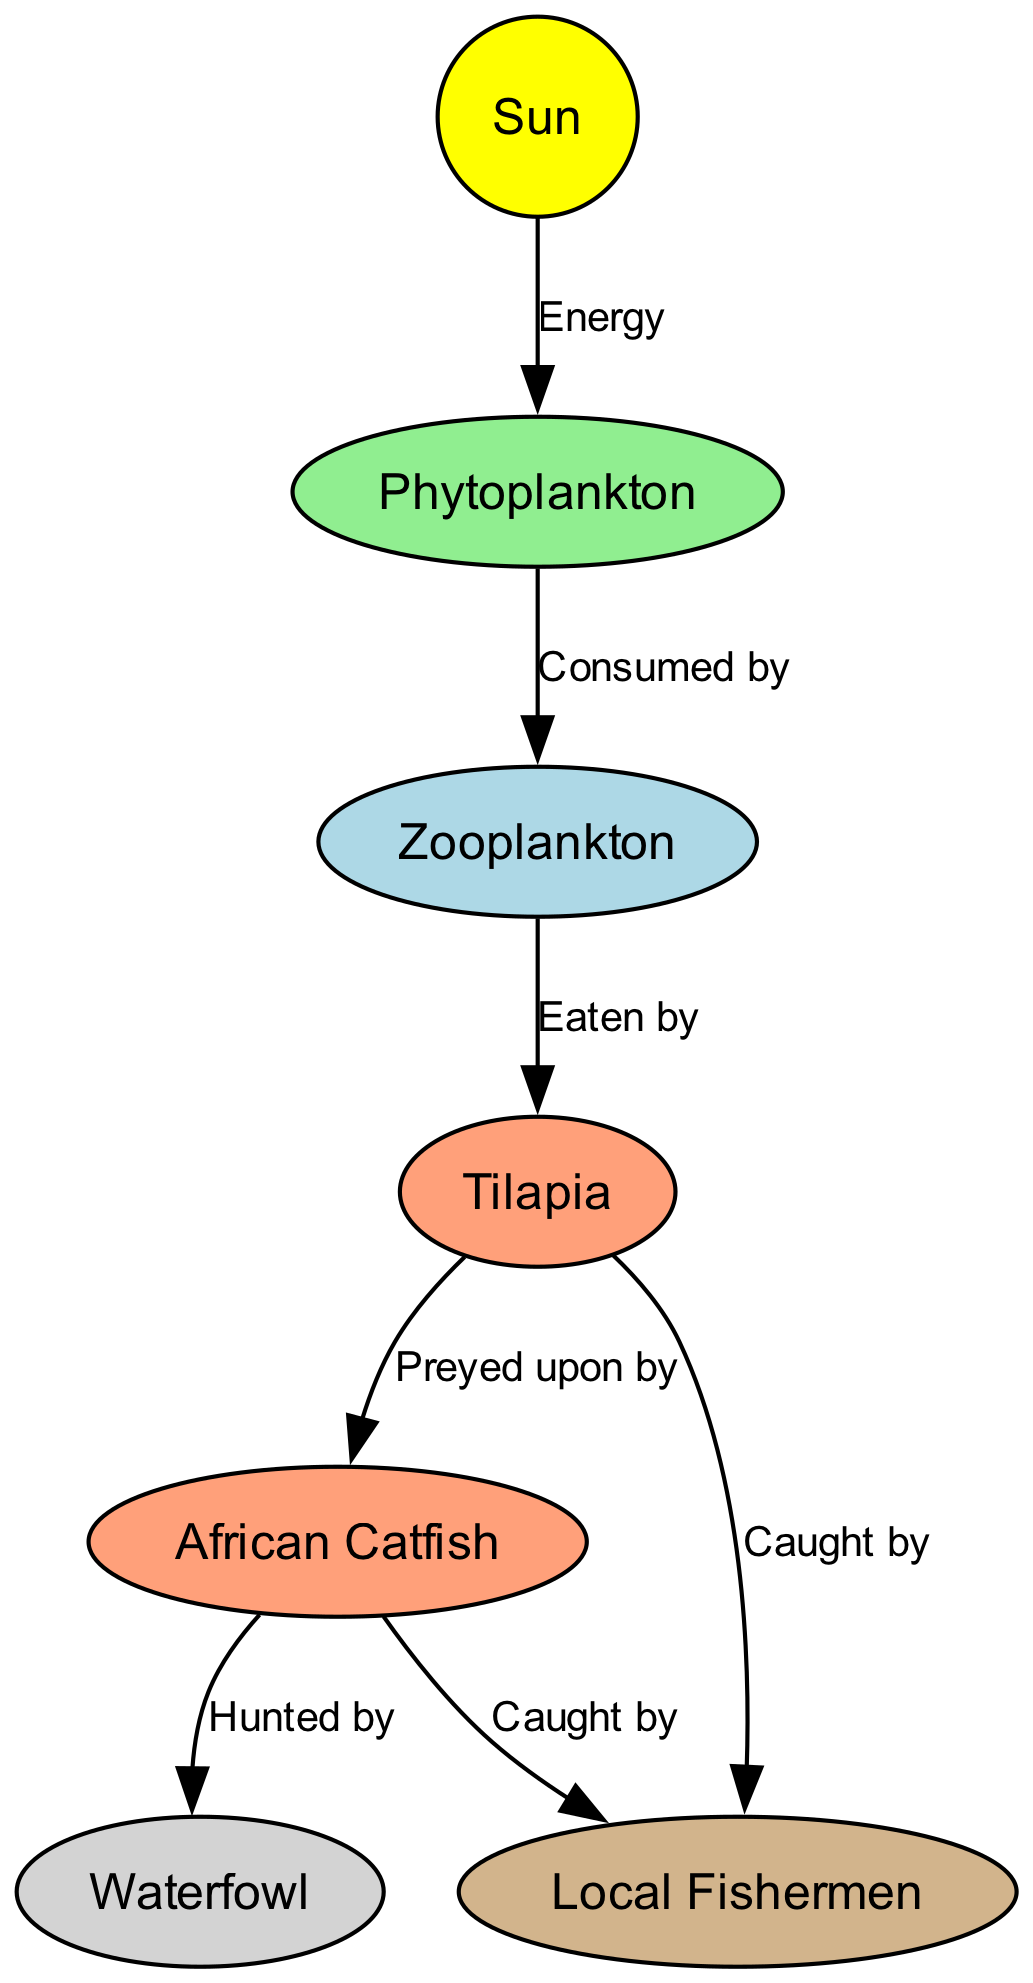What element is the primary source of energy in the food chain? The diagram shows the Sun at the top as the primary energy source, directing energy towards phytoplankton.
Answer: Sun How many types of fish are present in the food chain? The diagram includes two types of fish: Tilapia and African Catfish.
Answer: 2 Who are the final consumers in this food chain? On examining the diagram, the Waterfowl and Local Fishermen are indicated as the final consumers, consuming both Catfish and Tilapia.
Answer: Waterfowl, Local Fishermen What is the relationship between zooplankton and phytoplankton? The diagram displays an arrow from phytoplankton to zooplankton labeled "Consumed by," indicating that zooplankton consumes phytoplankton.
Answer: Consumed by Which element preys on tilapia? In the food chain, the diagram clearly shows that African Catfish is indicated as the predator of tilapia, represented by the arrow labeled "Preyed upon by."
Answer: African Catfish How many total connections or edges are shown in the diagram? By counting all the arrows and relationships represented in the diagram, there are a total of six edges connecting different elements.
Answer: 6 What do local fishermen catch in this food chain? The diagram illustrates that Local Fishermen catch both Tilapia and African Catfish, which are two arrows pointing to humans labeled "Caught by."
Answer: Tilapia, African Catfish What is the intermediate consumer between phytoplankton and tilapia? The diagram shows that zooplankton is the intermediate consumer that consumes phytoplankton and is subsequently eaten by tilapia.
Answer: Zooplankton 